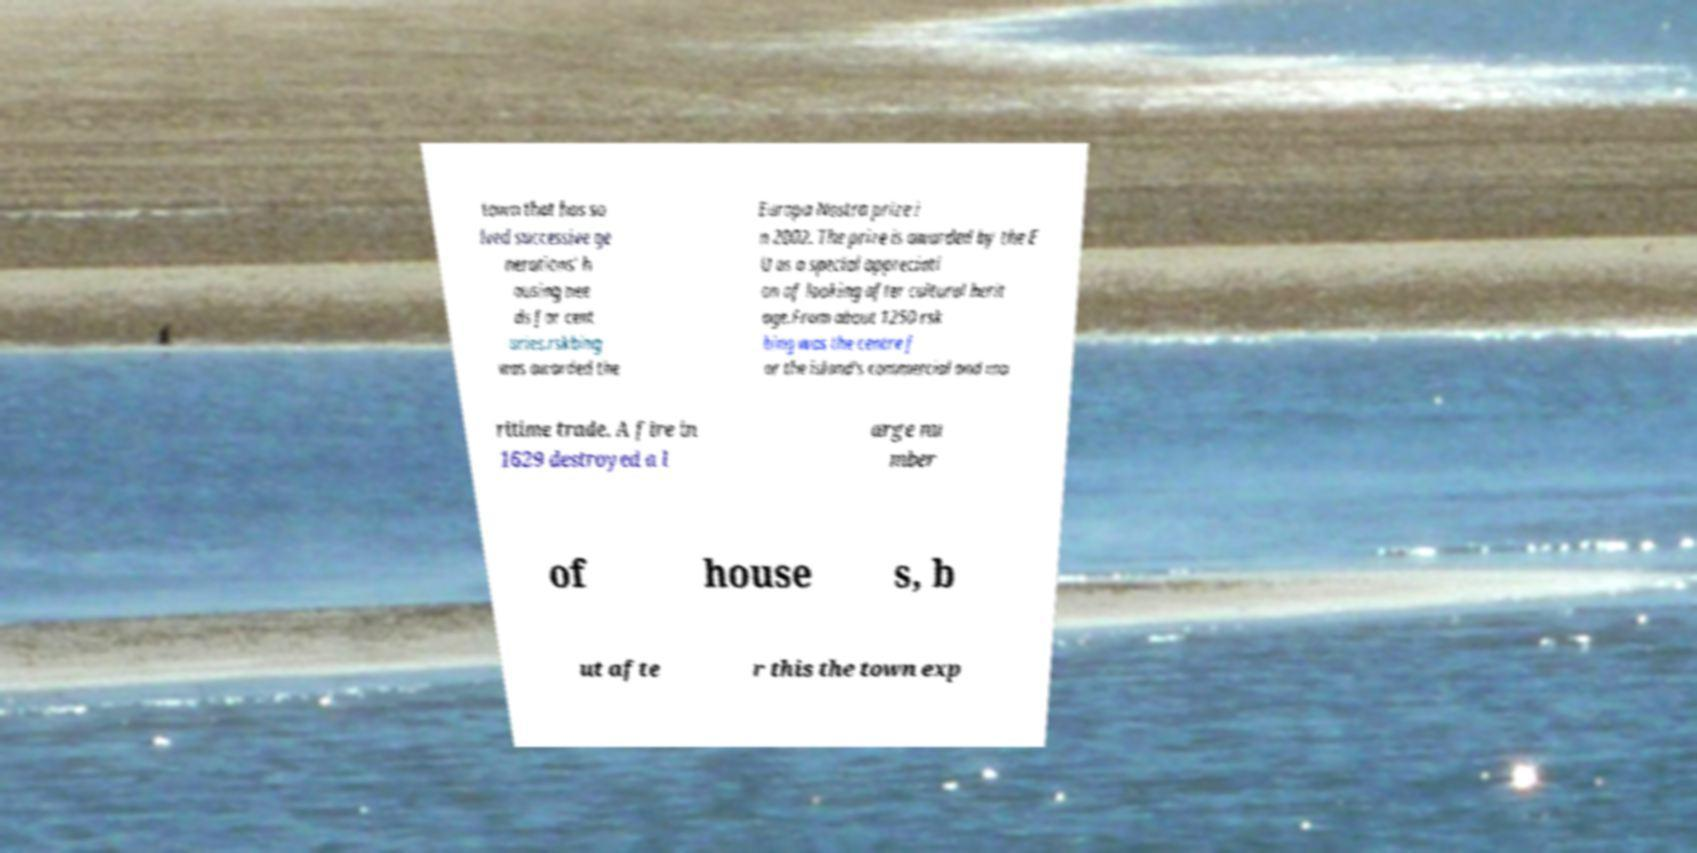Could you extract and type out the text from this image? town that has so lved successive ge nerations' h ousing nee ds for cent uries.rskbing was awarded the Europa Nostra prize i n 2002. The prize is awarded by the E U as a special appreciati on of looking after cultural herit age.From about 1250 rsk bing was the centre f or the island's commercial and ma ritime trade. A fire in 1629 destroyed a l arge nu mber of house s, b ut afte r this the town exp 